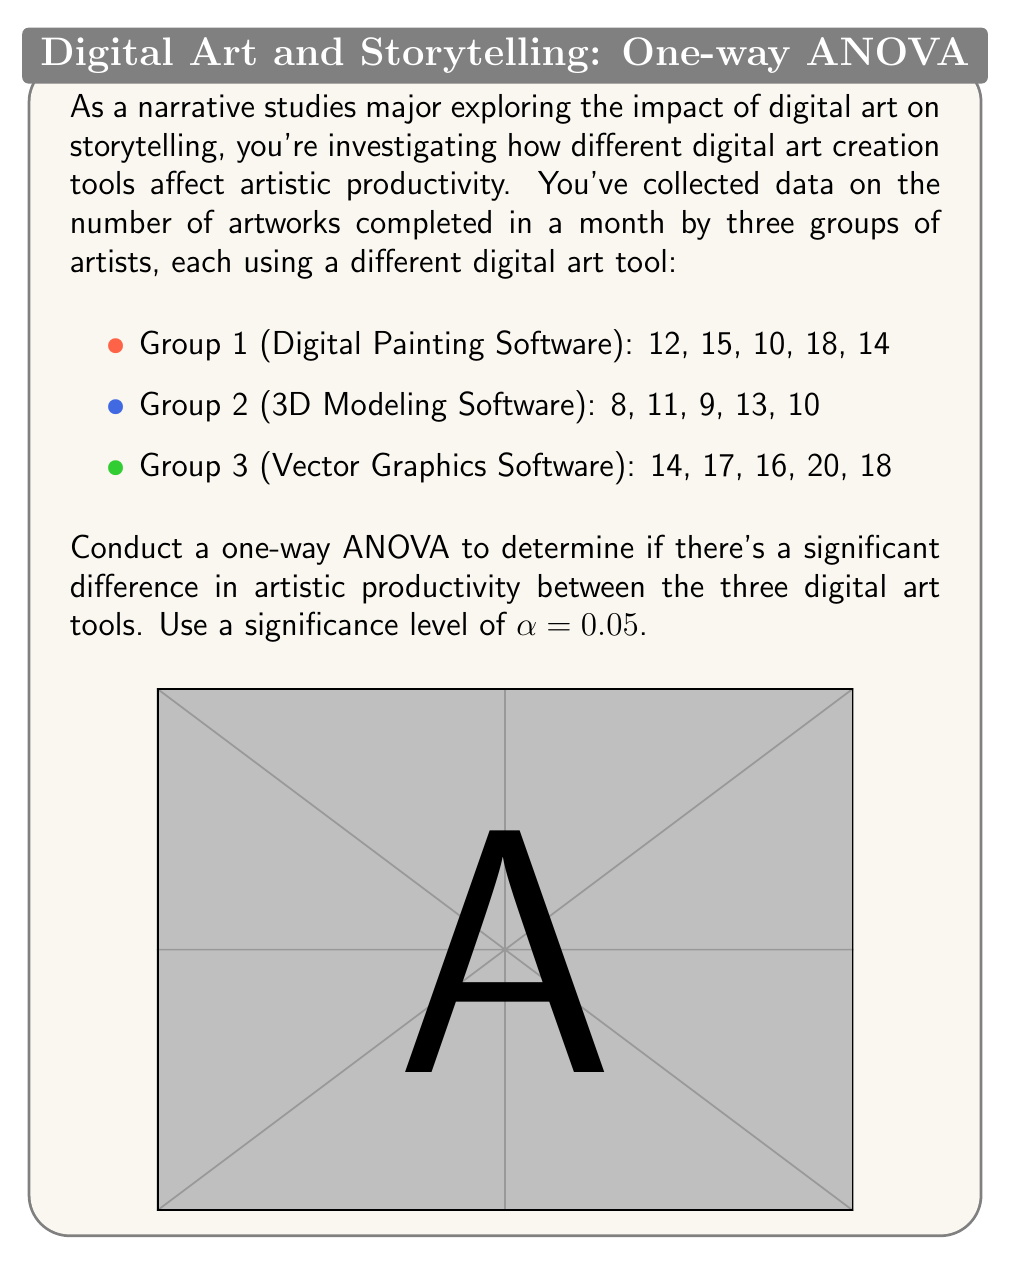Help me with this question. Let's solve this problem step-by-step using one-way ANOVA:

1) First, calculate the sum, mean, and sum of squares for each group:

   Group 1: Sum = 69, Mean = 13.8, SS = 62.8
   Group 2: Sum = 51, Mean = 10.2, SS = 26.8
   Group 3: Sum = 85, Mean = 17.0, SS = 34.0

2) Calculate the total sum of squares (SST):
   $$SST = \sum (x - \bar{x})^2 = 62.8 + 26.8 + 34.0 + 2(13.8 - 13.67)^2 + 5(10.2 - 13.67)^2 + 5(17.0 - 13.67)^2 = 195.73$$

3) Calculate the between-group sum of squares (SSB):
   $$SSB = 5(13.8 - 13.67)^2 + 5(10.2 - 13.67)^2 + 5(17.0 - 13.67)^2 = 123.73$$

4) Calculate the within-group sum of squares (SSW):
   $$SSW = SST - SSB = 195.73 - 123.73 = 72$$

5) Calculate degrees of freedom:
   $$df_{between} = k - 1 = 3 - 1 = 2$$
   $$df_{within} = N - k = 15 - 3 = 12$$
   $$df_{total} = N - 1 = 15 - 1 = 14$$

6) Calculate mean squares:
   $$MS_{between} = SSB / df_{between} = 123.73 / 2 = 61.865$$
   $$MS_{within} = SSW / df_{within} = 72 / 12 = 6$$

7) Calculate the F-statistic:
   $$F = MS_{between} / MS_{within} = 61.865 / 6 = 10.31$$

8) Find the critical F-value:
   For α = 0.05, df_between = 2, and df_within = 12, F_critical ≈ 3.89

9) Compare F to F_critical:
   Since 10.31 > 3.89, we reject the null hypothesis.

Therefore, there is a significant difference in artistic productivity between the three digital art tools at the 0.05 significance level.
Answer: $F(2,12) = 10.31, p < 0.05$. Reject null hypothesis. 